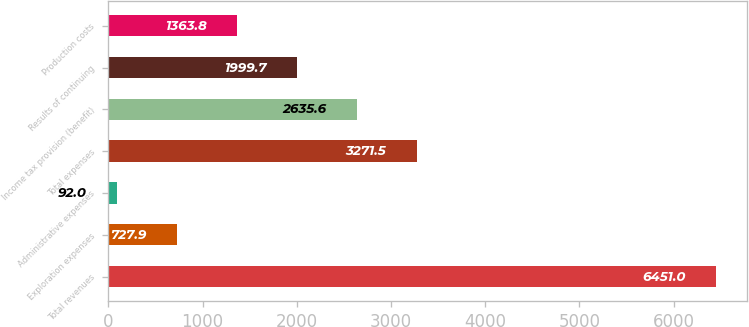Convert chart to OTSL. <chart><loc_0><loc_0><loc_500><loc_500><bar_chart><fcel>Total revenues<fcel>Exploration expenses<fcel>Administrative expenses<fcel>Total expenses<fcel>Income tax provision (benefit)<fcel>Results of continuing<fcel>Production costs<nl><fcel>6451<fcel>727.9<fcel>92<fcel>3271.5<fcel>2635.6<fcel>1999.7<fcel>1363.8<nl></chart> 